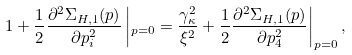<formula> <loc_0><loc_0><loc_500><loc_500>1 + \frac { 1 } { 2 } \frac { \partial ^ { 2 } \Sigma _ { H , 1 } ( p ) } { \partial p _ { i } ^ { 2 } } \left | _ { p = 0 } = \frac { \gamma _ { \kappa } ^ { 2 } } { \xi ^ { 2 } } + \frac { 1 } { 2 } \frac { \partial ^ { 2 } \Sigma _ { H , 1 } ( p ) } { \partial p _ { 4 } ^ { 2 } } \right | _ { p = 0 } ,</formula> 